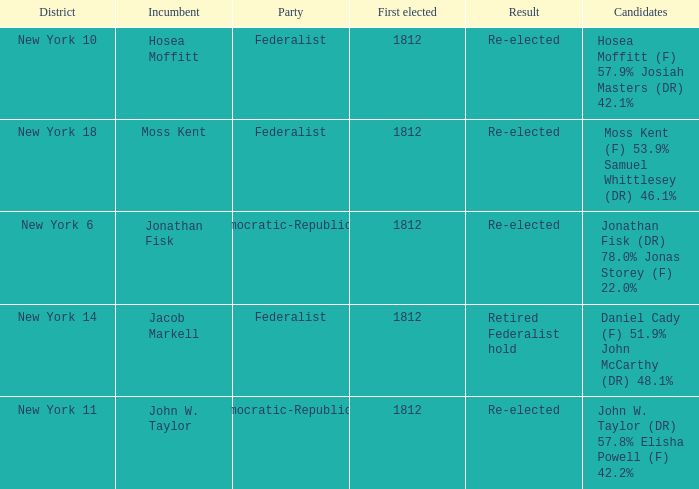Name the least first elected 1812.0. 